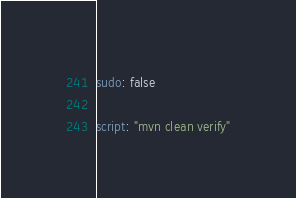Convert code to text. <code><loc_0><loc_0><loc_500><loc_500><_YAML_>sudo: false

script: "mvn clean verify"
</code> 